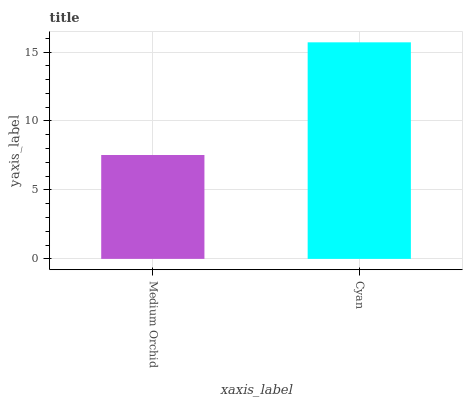Is Medium Orchid the minimum?
Answer yes or no. Yes. Is Cyan the maximum?
Answer yes or no. Yes. Is Cyan the minimum?
Answer yes or no. No. Is Cyan greater than Medium Orchid?
Answer yes or no. Yes. Is Medium Orchid less than Cyan?
Answer yes or no. Yes. Is Medium Orchid greater than Cyan?
Answer yes or no. No. Is Cyan less than Medium Orchid?
Answer yes or no. No. Is Cyan the high median?
Answer yes or no. Yes. Is Medium Orchid the low median?
Answer yes or no. Yes. Is Medium Orchid the high median?
Answer yes or no. No. Is Cyan the low median?
Answer yes or no. No. 